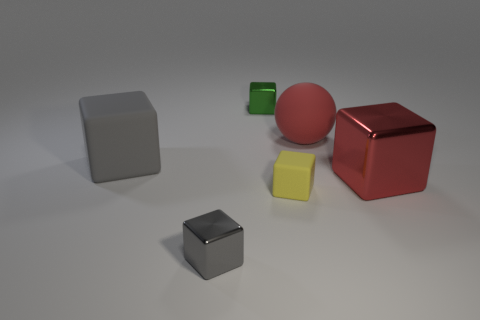Is the sphere the same color as the big metallic cube?
Provide a short and direct response. Yes. There is a small thing that is in front of the small matte object; is it the same color as the big matte block?
Ensure brevity in your answer.  Yes. Is there anything else that has the same color as the big shiny cube?
Ensure brevity in your answer.  Yes. There is a big red object on the left side of the large red metallic object; does it have the same shape as the tiny yellow object?
Your answer should be compact. No. How many metal objects are both left of the tiny yellow object and in front of the big red rubber thing?
Ensure brevity in your answer.  1. What number of big objects are the same shape as the small yellow object?
Provide a short and direct response. 2. There is a small shiny cube to the left of the small thing that is behind the large rubber ball; what is its color?
Make the answer very short. Gray. Does the small gray metal object have the same shape as the big gray thing that is to the left of the gray metal thing?
Provide a succinct answer. Yes. The big cube that is to the right of the big object that is on the left side of the tiny block that is behind the large red block is made of what material?
Your answer should be very brief. Metal. Are there any green blocks of the same size as the gray metallic block?
Offer a very short reply. Yes. 